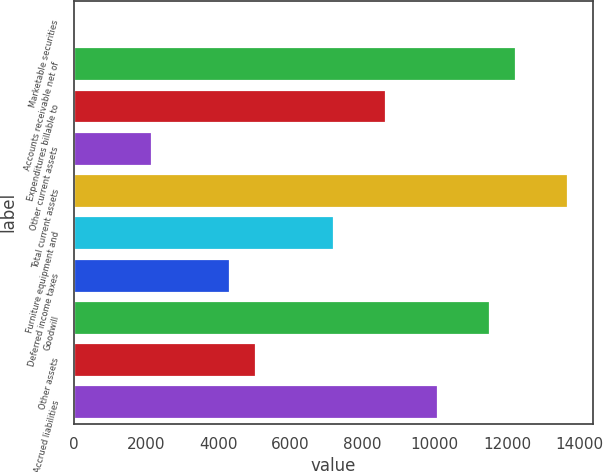Convert chart. <chart><loc_0><loc_0><loc_500><loc_500><bar_chart><fcel>Marketable securities<fcel>Accounts receivable net of<fcel>Expenditures billable to<fcel>Other current assets<fcel>Total current assets<fcel>Furniture equipment and<fcel>Deferred income taxes<fcel>Goodwill<fcel>Other assets<fcel>Accrued liabilities<nl><fcel>1.4<fcel>12254<fcel>8650.28<fcel>2163.62<fcel>13695.5<fcel>7208.8<fcel>4325.84<fcel>11533.2<fcel>5046.58<fcel>10091.8<nl></chart> 